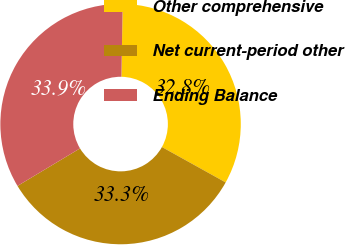Convert chart. <chart><loc_0><loc_0><loc_500><loc_500><pie_chart><fcel>Other comprehensive<fcel>Net current-period other<fcel>Ending Balance<nl><fcel>32.79%<fcel>33.33%<fcel>33.88%<nl></chart> 